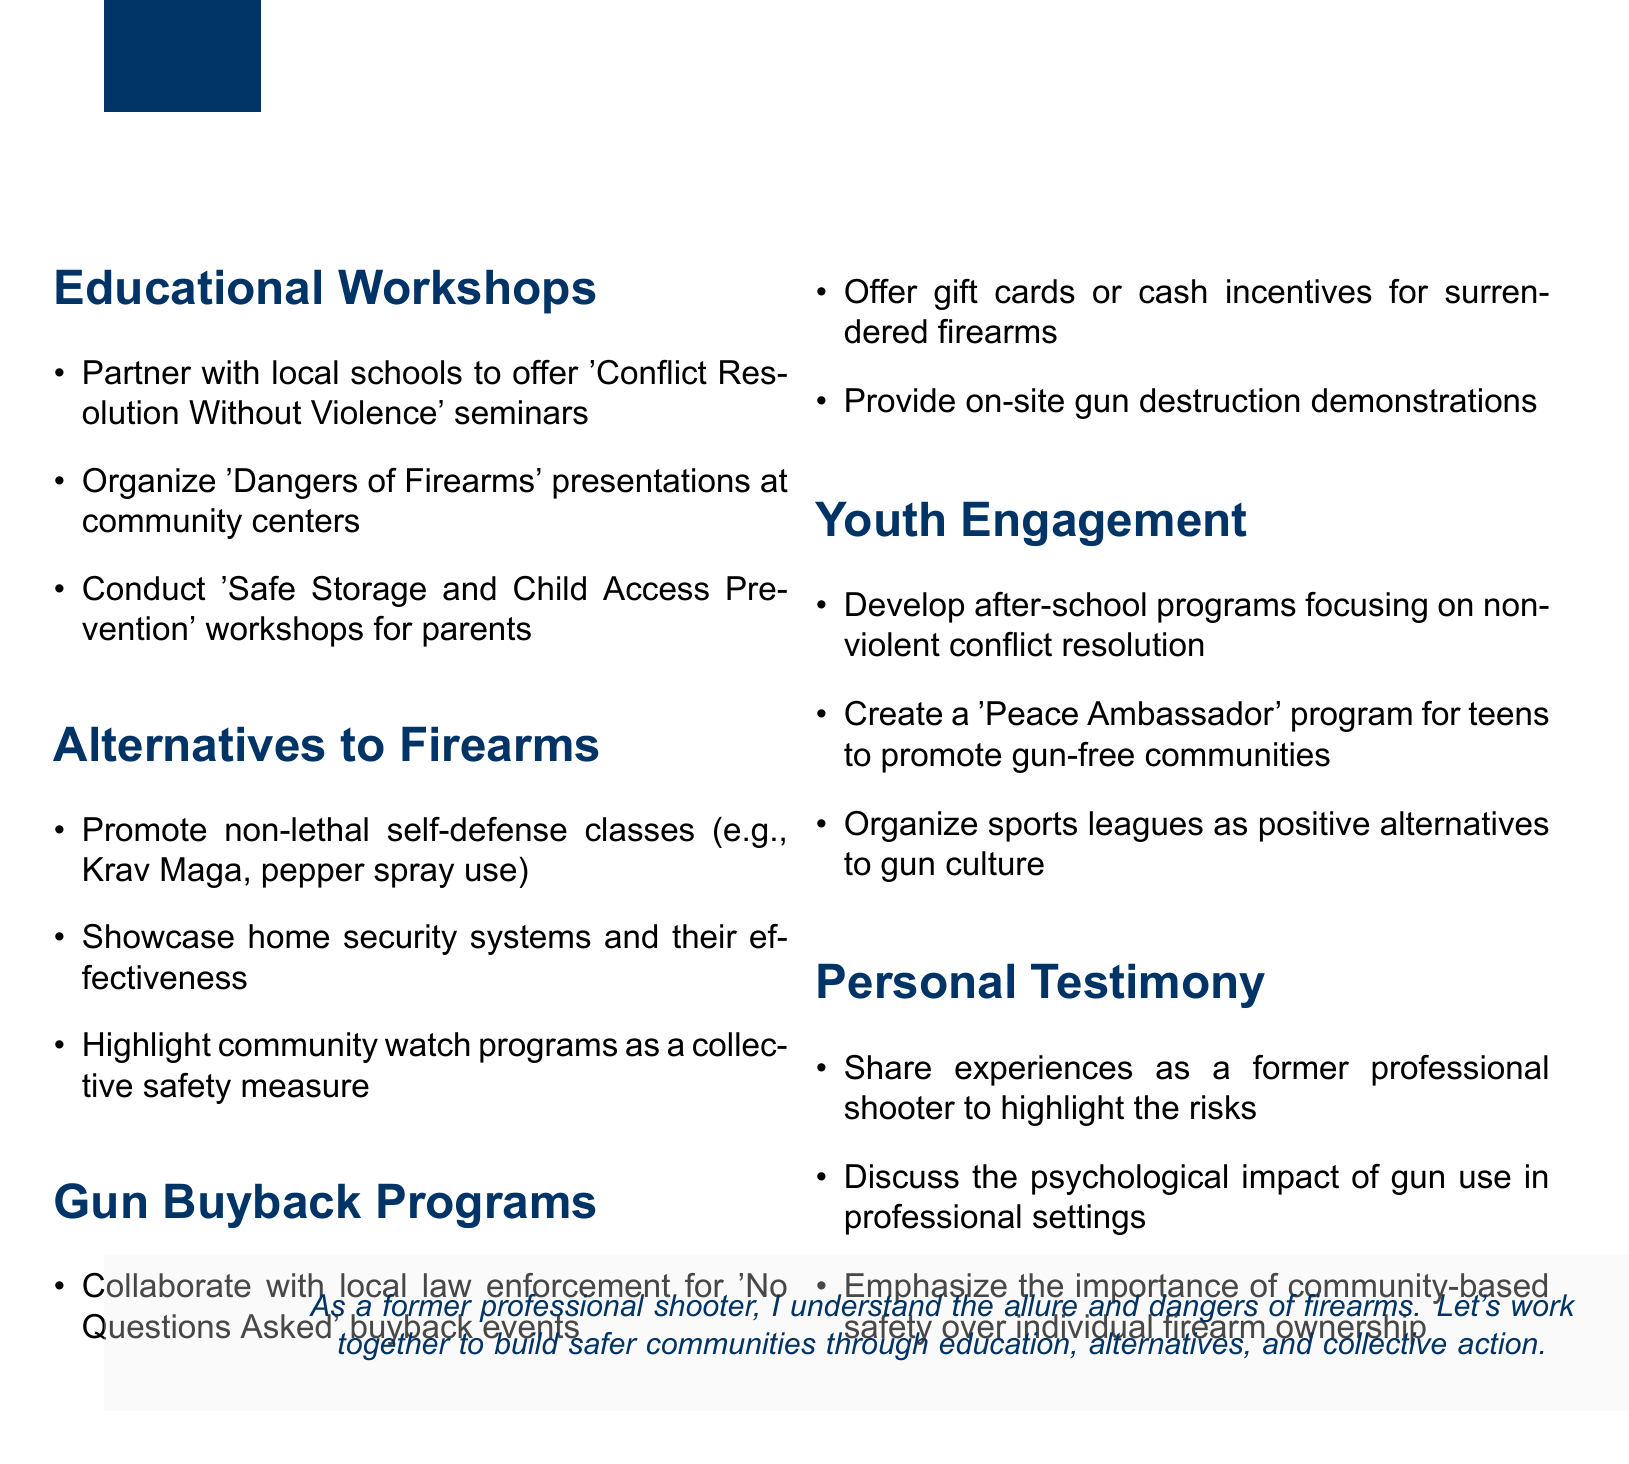What are the three main headings of the document? The document is organized into five main sections: Educational Workshops, Alternatives to Firearms, Gun Buyback Programs, Youth Engagement, and Personal Testimony.
Answer: Educational Workshops, Alternatives to Firearms, Gun Buyback Programs, Youth Engagement, Personal Testimony What type of seminars are suggested for local schools? The document indicates the type of seminars that are proposed to facilitate learning in schools, specifically to resolve conflicts without violence.
Answer: 'Conflict Resolution Without Violence' seminars What is one alternative to firearm ownership presented in the document? The document lists several alternatives to firearms, which includes non-lethal self-defense classes.
Answer: non-lethal self-defense classes How many points are listed under the 'Gun Buyback Programs' section? The document specifies three points in the 'Gun Buyback Programs' section, each addressing a different strategy for encouraging firearm surrender.
Answer: 3 What reward is suggested for participating in gun buyback events? The document outlines an incentive structure, indicating that participants can receive cash rewards or gift cards for surrendering firearms.
Answer: gift cards or cash incentives What community program is mentioned as a positive alternative to gun culture? Within the document, a specific program aimed at fostering positive community engagement and reducing gun culture is highlighted.
Answer: sports leagues What is emphasized as more important than individual firearm ownership? The document highlights a key concept regarding community safety, distinguishing the preference for communal safety methods over individual gun ownership.
Answer: community-based safety What unique personal perspective is included in the program? The document urges sharing a specific background to inform outreach, providing a framework for understanding the risks associated with firearms through firsthand experience.
Answer: experiences as a former professional shooter 